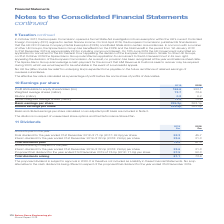According to Spirax Sarco Engineering Plc's financial document, On what basis is the basic and diluted earnings per share calculated on? an adjusted profit basis. The document states: "asic and diluted earnings per share calculated on an adjusted profit basis are included in Note 2...." Also, What is the dilution of earnings per share in respect of? unexercised share options and the Performance Share Plan.. The document states: "The dilution is in respect of unexercised share options and the Performance Share Plan...." Also, What are the types of earnings per share? The document shows two values: Basic and Diluted. From the document: "es (million) 73.7 73.6 Dilution (million) 0.2 0.2 Diluted weighted average shares (million) 73.9 73.8 Basic earnings per share 226.2p 303.1p Diluted e..." Additionally, In which year was the weighted average shares larger? According to the financial document, 2019. The relevant text states: "2019 2018 Profit attributable to equity shareholders (£m) 166.6 223.1 Weighted average shares (million)..." Also, can you calculate: What was the change in the profit attributable to equity shareholders from 2018 to 2019? Based on the calculation: 166.6-223.1, the result is -56.5 (in millions). This is based on the information: "8 Profit attributable to equity shareholders (£m) 166.6 223.1 Weighted average shares (million) 73.7 73.6 Dilution (million) 0.2 0.2 Diluted weighted avera it attributable to equity shareholders (£m) ..." The key data points involved are: 166.6, 223.1. Also, can you calculate: What was the percentage change in the profit attributable to equity shareholders from 2018 to 2019? To answer this question, I need to perform calculations using the financial data. The calculation is: (166.6-223.1)/223.1, which equals -25.32 (percentage). This is based on the information: "8 Profit attributable to equity shareholders (£m) 166.6 223.1 Weighted average shares (million) 73.7 73.6 Dilution (million) 0.2 0.2 Diluted weighted avera it attributable to equity shareholders (£m) ..." The key data points involved are: 166.6, 223.1. 